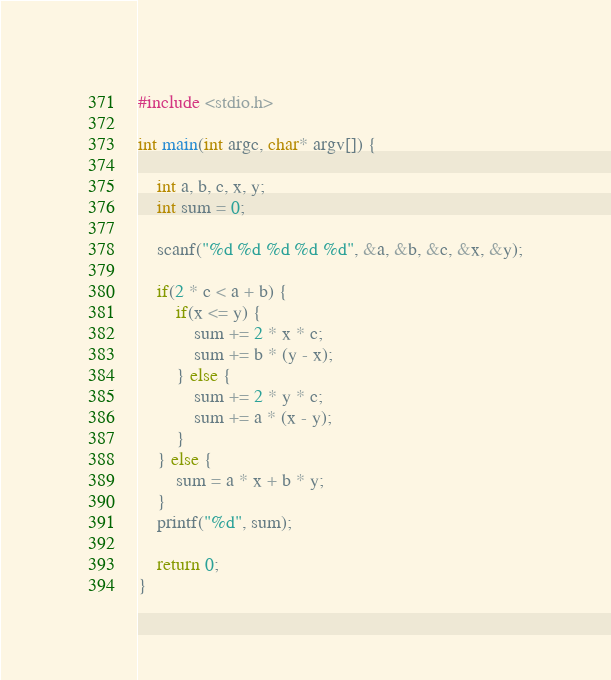<code> <loc_0><loc_0><loc_500><loc_500><_C_>#include <stdio.h>

int main(int argc, char* argv[]) {

	int a, b, c, x, y;
	int sum = 0;

	scanf("%d %d %d %d %d", &a, &b, &c, &x, &y);

	if(2 * c < a + b) {
		if(x <= y) {
			sum += 2 * x * c;
			sum += b * (y - x);
		} else {
			sum += 2 * y * c;
			sum += a * (x - y);
		}
	} else {
		sum = a * x + b * y;
	}
	printf("%d", sum);

	return 0;
}</code> 